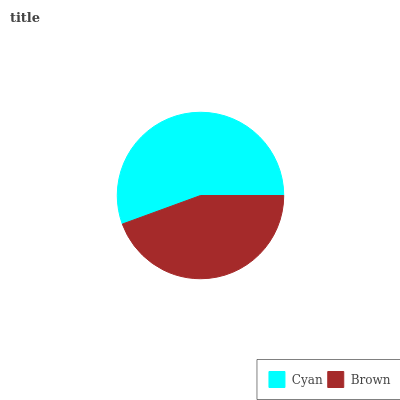Is Brown the minimum?
Answer yes or no. Yes. Is Cyan the maximum?
Answer yes or no. Yes. Is Brown the maximum?
Answer yes or no. No. Is Cyan greater than Brown?
Answer yes or no. Yes. Is Brown less than Cyan?
Answer yes or no. Yes. Is Brown greater than Cyan?
Answer yes or no. No. Is Cyan less than Brown?
Answer yes or no. No. Is Cyan the high median?
Answer yes or no. Yes. Is Brown the low median?
Answer yes or no. Yes. Is Brown the high median?
Answer yes or no. No. Is Cyan the low median?
Answer yes or no. No. 